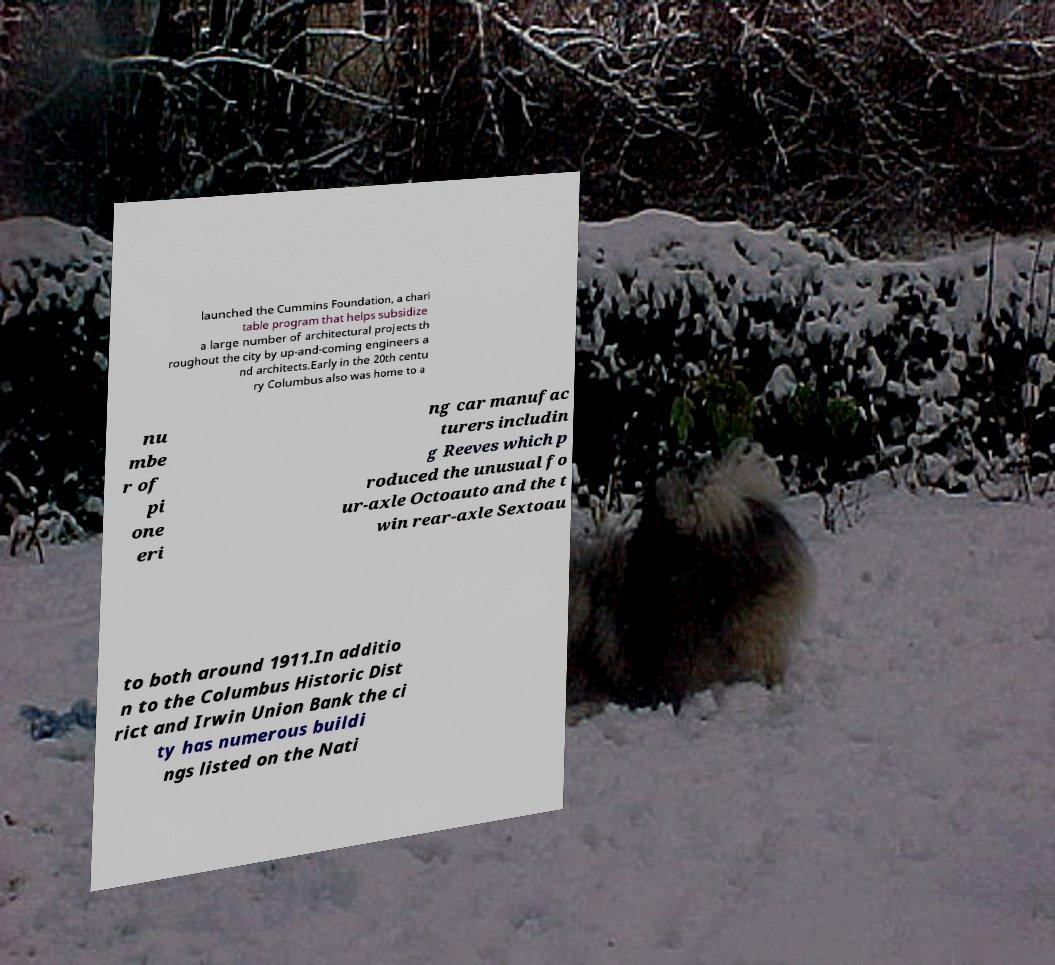Could you extract and type out the text from this image? launched the Cummins Foundation, a chari table program that helps subsidize a large number of architectural projects th roughout the city by up-and-coming engineers a nd architects.Early in the 20th centu ry Columbus also was home to a nu mbe r of pi one eri ng car manufac turers includin g Reeves which p roduced the unusual fo ur-axle Octoauto and the t win rear-axle Sextoau to both around 1911.In additio n to the Columbus Historic Dist rict and Irwin Union Bank the ci ty has numerous buildi ngs listed on the Nati 